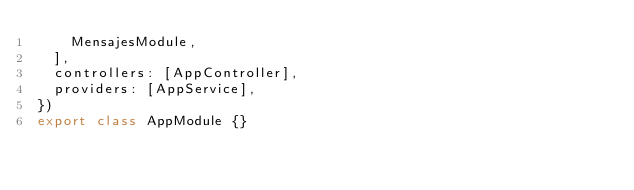<code> <loc_0><loc_0><loc_500><loc_500><_TypeScript_>    MensajesModule,
  ],
  controllers: [AppController],
  providers: [AppService],
})
export class AppModule {}
</code> 